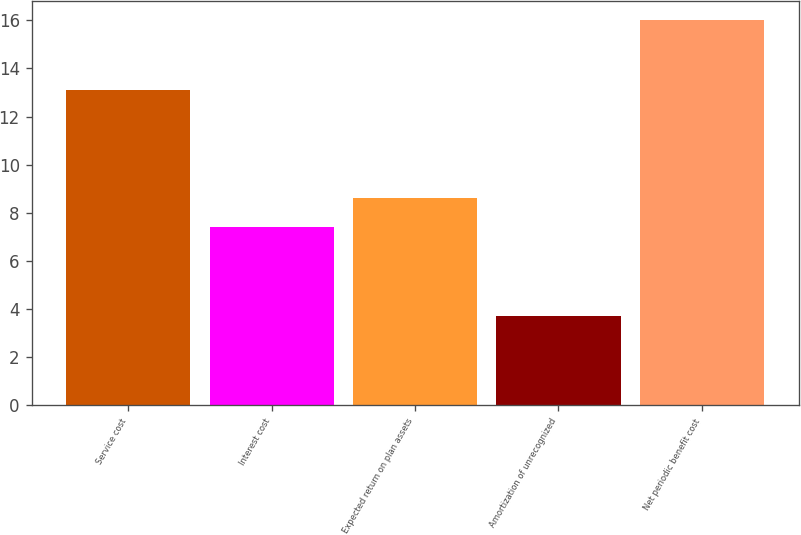Convert chart. <chart><loc_0><loc_0><loc_500><loc_500><bar_chart><fcel>Service cost<fcel>Interest cost<fcel>Expected return on plan assets<fcel>Amortization of unrecognized<fcel>Net periodic benefit cost<nl><fcel>13.1<fcel>7.4<fcel>8.63<fcel>3.7<fcel>16<nl></chart> 